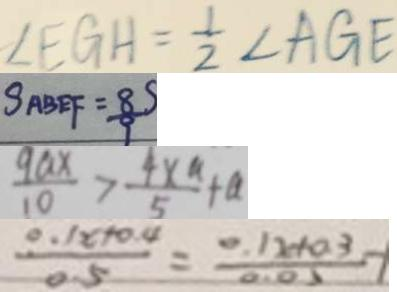Convert formula to latex. <formula><loc_0><loc_0><loc_500><loc_500>\angle E G H = \frac { 1 } { 2 } \angle A G E 
 S _ { A B E F } = \frac { 8 . S } { 9 } 
 \frac { 9 a x } { 1 0 } > \frac { 4 x ^ { a } } { 5 } + a 
 \frac { 0 . 1 x + 0 . 4 } { 5 } = \frac { 0 . 1 x + a 3 } { 0 . 0 5 }</formula> 